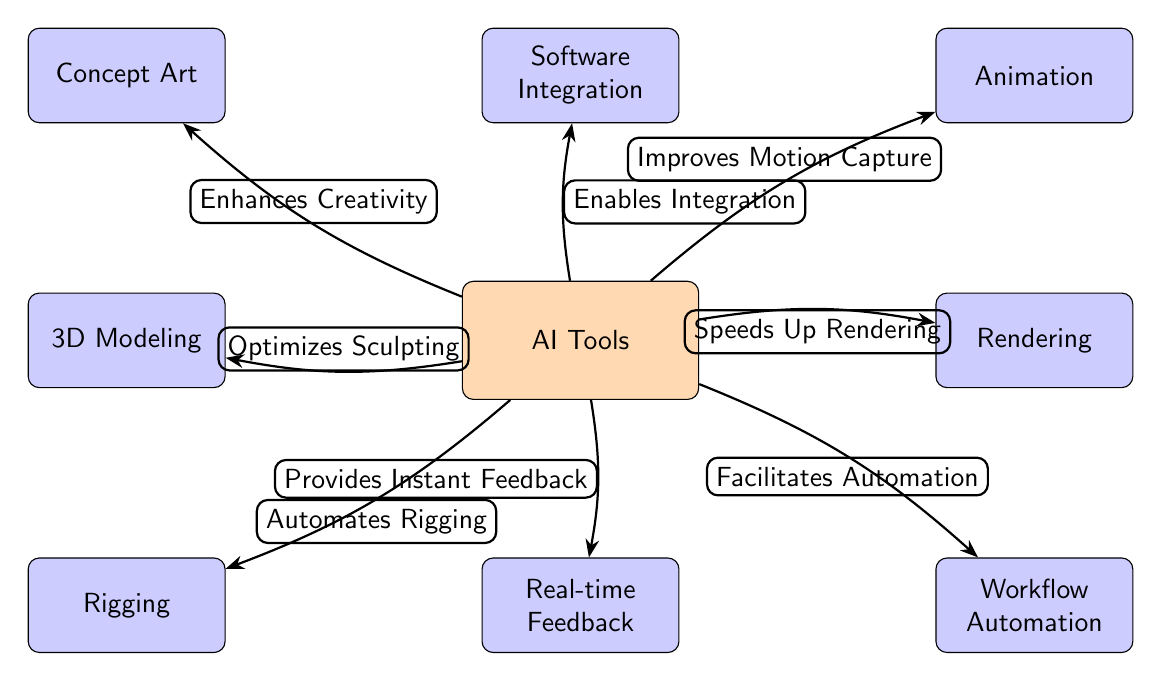What is the main focus of this diagram? The diagram primarily emphasizes the role of AI tools in enhancing various aspects of 3D animation and sculpting workflows.
Answer: AI Tools How many nodes are present in the diagram? By counting the distinct elements, there are a total of 8 nodes representing different processes and AI tools.
Answer: 8 Which process is directly linked to AI Tools with "Automates Rigging"? The "Automates Rigging" label connects the AI Tools node specifically to the Rigging process node in the diagram.
Answer: Rigging What does the "Enhances Creativity" edge connect? The edge labeled "Enhances Creativity" connects the AI Tools node with the Concept Art process node, highlighting how AI can boost creativity in conceptual work.
Answer: Concept Art Which two processes are linked to the AI Tools node with edges that emphasize speed? The nodes linked to AI Tools that focus on speed are Rendering and Workflow Automation, indicating AI's role in increasing efficiency in these areas.
Answer: Rendering and Workflow Automation What is the relationship between AI Tools and Software Integration? The edge connecting AI Tools to Software Integration indicates that AI facilitates the process of integrating different software solutions used in 3D animation.
Answer: Enables Integration Which process receives "Real-time Feedback" from AI Tools? The edge labeled "Provides Instant Feedback" connects the AI Tools node to the Feedback process node, showing that AI offers immediate critiques or suggestions.
Answer: Feedback Which process optimizes sculpting according to the diagram? The arrow connected to AI Tools labeled "Optimizes Sculpting" associates AI directly with the 3D Modeling process.
Answer: 3D Modeling What is the flow direction of the relationship between AI Tools and Animation? The relationship demonstrates a flow from AI Tools to the Animation process, labeled "Improves Motion Capture," indicating the enhancement of animation techniques.
Answer: From AI Tools to Animation 